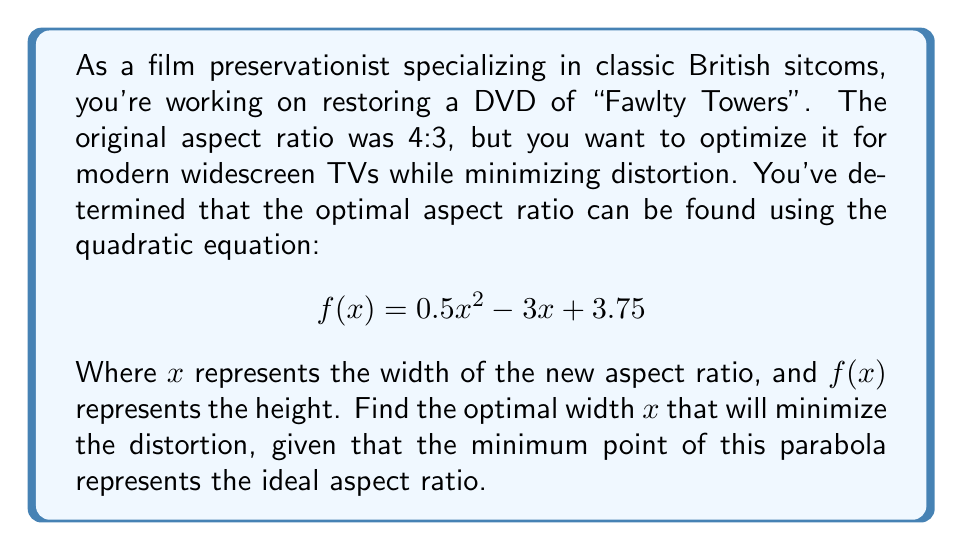Could you help me with this problem? To find the optimal width that minimizes distortion, we need to find the vertex of the parabola represented by the quadratic equation. The vertex represents the minimum point of the parabola, which in this case corresponds to the optimal aspect ratio.

For a quadratic equation in the form $f(x) = ax^2 + bx + c$, the x-coordinate of the vertex is given by $x = -\frac{b}{2a}$.

In our equation $f(x) = 0.5x^2 - 3x + 3.75$:
$a = 0.5$
$b = -3$
$c = 3.75$

Plugging these values into the vertex formula:

$$x = -\frac{b}{2a} = -\frac{(-3)}{2(0.5)} = \frac{3}{1} = 3$$

Therefore, the optimal width for the new aspect ratio is 3.

To find the corresponding height, we substitute $x = 3$ into the original equation:

$$\begin{align}
f(3) &= 0.5(3)^2 - 3(3) + 3.75 \\
&= 0.5(9) - 9 + 3.75 \\
&= 4.5 - 9 + 3.75 \\
&= -0.75
\end{align}$$

The absolute value of this result gives us the height: $|-0.75| = 0.75$

Thus, the optimal aspect ratio is 3:0.75, which simplifies to 4:1.
Answer: The optimal width is 3, resulting in an aspect ratio of 4:1. 